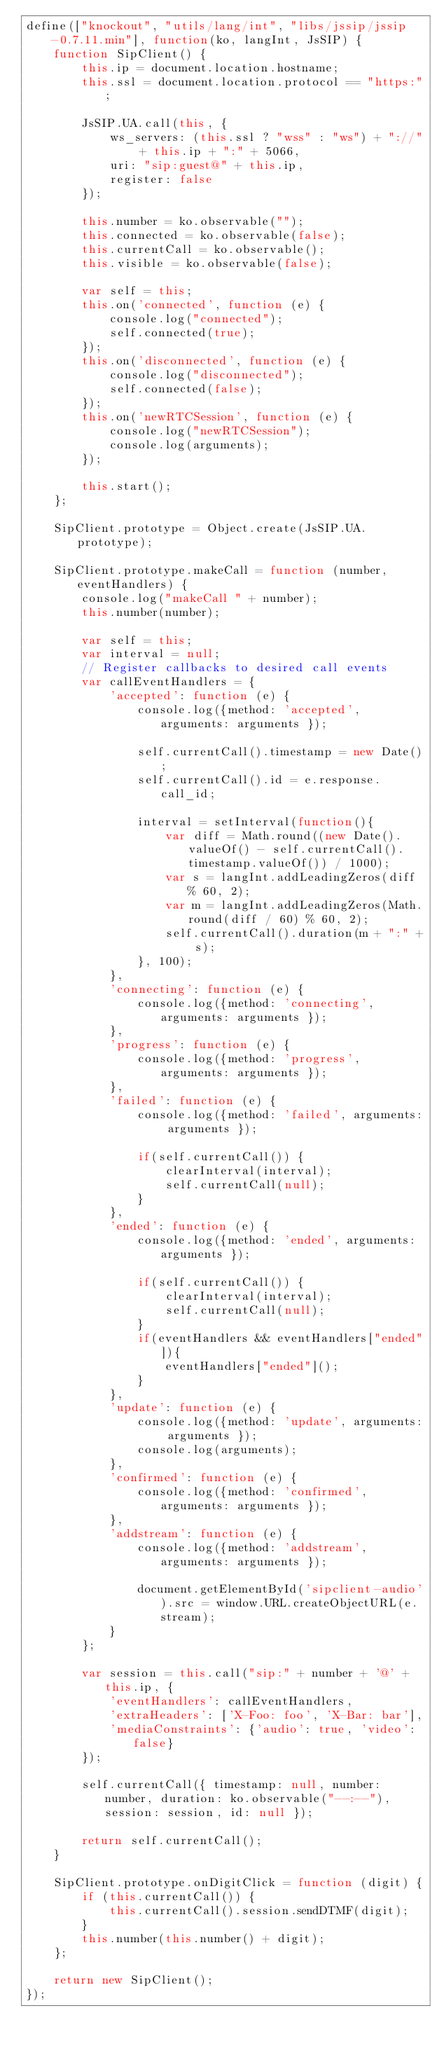<code> <loc_0><loc_0><loc_500><loc_500><_JavaScript_>define(["knockout", "utils/lang/int", "libs/jssip/jssip-0.7.11.min"], function(ko, langInt, JsSIP) {
    function SipClient() {
        this.ip = document.location.hostname;
        this.ssl = document.location.protocol == "https:";

        JsSIP.UA.call(this, {
            ws_servers: (this.ssl ? "wss" : "ws") + "://" + this.ip + ":" + 5066,
            uri: "sip:guest@" + this.ip,
            register: false
        });

        this.number = ko.observable("");
        this.connected = ko.observable(false);
        this.currentCall = ko.observable();
        this.visible = ko.observable(false);

        var self = this;
        this.on('connected', function (e) {
            console.log("connected");
            self.connected(true);
        });
        this.on('disconnected', function (e) {
            console.log("disconnected");
            self.connected(false);
        });
        this.on('newRTCSession', function (e) {
            console.log("newRTCSession");
            console.log(arguments);
        });

        this.start();
    };

    SipClient.prototype = Object.create(JsSIP.UA.prototype);

    SipClient.prototype.makeCall = function (number, eventHandlers) {
        console.log("makeCall " + number);
        this.number(number);

        var self = this;
        var interval = null;
        // Register callbacks to desired call events
        var callEventHandlers = {
            'accepted': function (e) {
                console.log({method: 'accepted', arguments: arguments });

                self.currentCall().timestamp = new Date();
                self.currentCall().id = e.response.call_id;

                interval = setInterval(function(){
                    var diff = Math.round((new Date().valueOf() - self.currentCall().timestamp.valueOf()) / 1000);
                    var s = langInt.addLeadingZeros(diff % 60, 2);
                    var m = langInt.addLeadingZeros(Math.round(diff / 60) % 60, 2);
                    self.currentCall().duration(m + ":" + s);
                }, 100);
            },
            'connecting': function (e) {
                console.log({method: 'connecting', arguments: arguments });
            },
            'progress': function (e) {
                console.log({method: 'progress', arguments: arguments });
            },
            'failed': function (e) {
                console.log({method: 'failed', arguments: arguments });

                if(self.currentCall()) {
                    clearInterval(interval);
                    self.currentCall(null);
                }
            },
            'ended': function (e) {
                console.log({method: 'ended', arguments: arguments });

                if(self.currentCall()) {
                    clearInterval(interval);
                    self.currentCall(null);
                }
                if(eventHandlers && eventHandlers["ended"]){
                    eventHandlers["ended"]();
                }
            },
            'update': function (e) {
                console.log({method: 'update', arguments: arguments });
                console.log(arguments);
            },
            'confirmed': function (e) {
                console.log({method: 'confirmed', arguments: arguments });
            },
            'addstream': function (e) {
                console.log({method: 'addstream', arguments: arguments });

                document.getElementById('sipclient-audio').src = window.URL.createObjectURL(e.stream);
            }
        };

        var session = this.call("sip:" + number + '@' + this.ip, {
            'eventHandlers': callEventHandlers,
            'extraHeaders': ['X-Foo: foo', 'X-Bar: bar'],
            'mediaConstraints': {'audio': true, 'video': false}
        });

        self.currentCall({ timestamp: null, number: number, duration: ko.observable("--:--"), session: session, id: null });

        return self.currentCall();
    }

    SipClient.prototype.onDigitClick = function (digit) {
        if (this.currentCall()) {
            this.currentCall().session.sendDTMF(digit);
        }
        this.number(this.number() + digit);
    };

    return new SipClient();
});</code> 